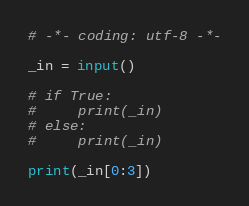Convert code to text. <code><loc_0><loc_0><loc_500><loc_500><_Python_># -*- coding: utf-8 -*-

_in = input()

# if True:
#     print(_in)
# else:
#     print(_in)

print(_in[0:3])
</code> 